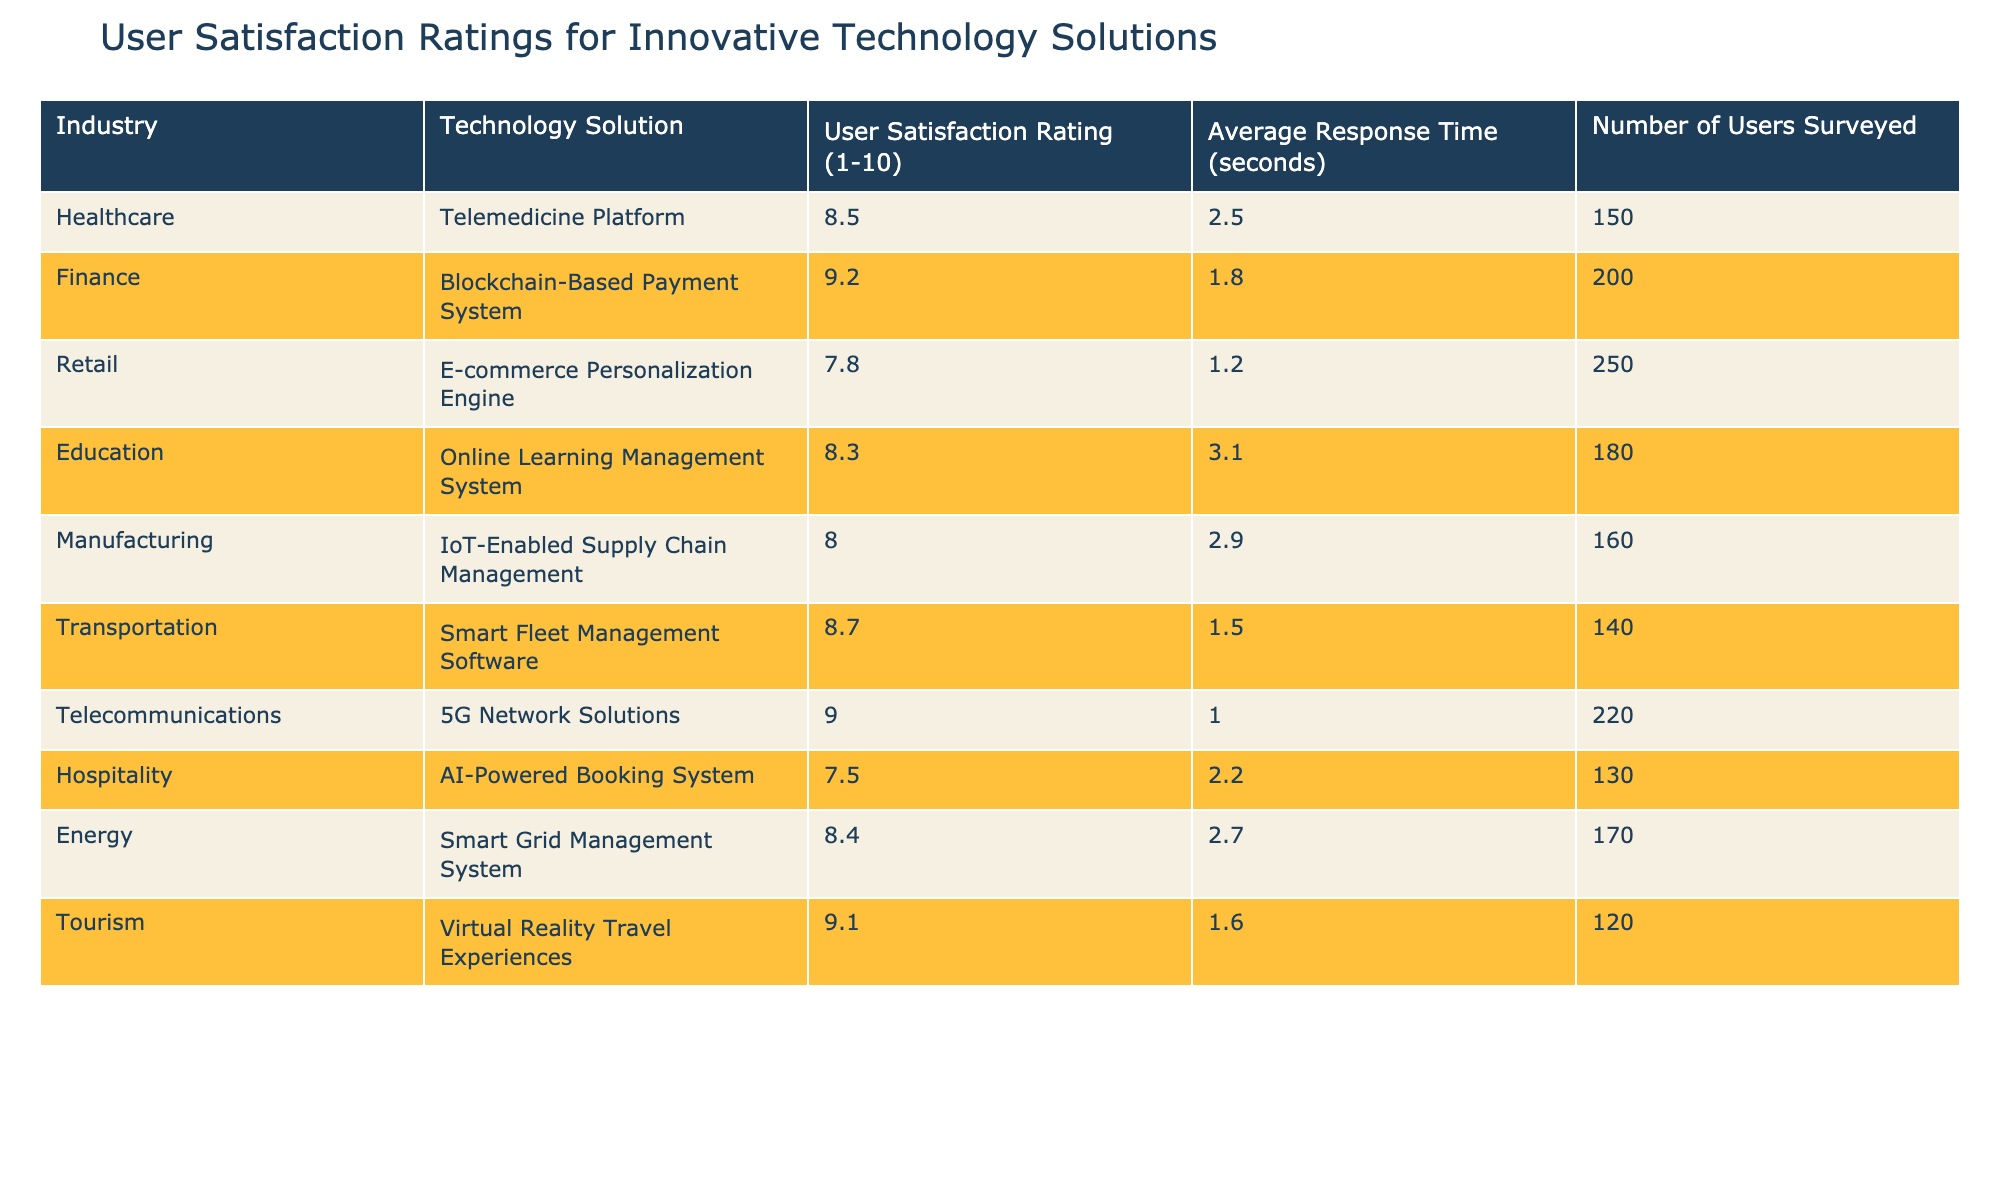What is the highest user satisfaction rating among the technology solutions? The table shows user satisfaction ratings for various technology solutions. Upon reviewing the ratings, the highest rating listed is 9.2 for the Blockchain-Based Payment System in the Finance industry.
Answer: 9.2 What is the average user satisfaction rating for the Healthcare and Education industries? The user satisfaction ratings for Healthcare and Education are 8.5 and 8.3, respectively. To calculate the average, add these two ratings (8.5 + 8.3 = 16.8) and divide by the number of industries, which is 2. Thus, the average is 16.8 / 2 = 8.4.
Answer: 8.4 Is the Average Response Time for the Tourism technology solution less than the average response time for the Energy technology solution? The Average Response Time for the Virtual Reality Travel Experiences in Tourism is 1.6 seconds, while for Smart Grid Management System in Energy, it is 2.7 seconds. Since 1.6 is less than 2.7, the statement is true.
Answer: Yes What is the user satisfaction rating difference between the Smart Fleet Management Software and AI-Powered Booking System? The user satisfaction ratings are 8.7 for Smart Fleet Management Software in Transportation and 7.5 for AI-Powered Booking System in Hospitality. To find the difference, subtract the lower rating from the higher rating: 8.7 - 7.5 = 1.2.
Answer: 1.2 How many users were surveyed for the E-commerce Personalization Engine, and is it more than the number of users surveyed for the Smart Fleet Management Software? The number of users surveyed for the E-commerce Personalization Engine in Retail is 250, while for Smart Fleet Management Software in Transportation, it is 140. Comparing these values, 250 is greater than 140.
Answer: Yes What is the average number of users surveyed across all technology solutions? To find the average number of users surveyed, we first sum the number of users from each solution: (150 + 200 + 250 + 180 + 160 + 140 + 220 + 130 + 170 + 120) = 1,870. Then, divide by the number of solutions, which is 10. The average is 1,870 / 10 = 187.
Answer: 187 Which industry has the lowest user satisfaction rating, and what is that rating? By reviewing the user satisfaction ratings in the table, the lowest rating is 7.5 for the AI-Powered Booking System in the Hospitality industry.
Answer: Hospitality, 7.5 Compare the Average Response Times for the Blockchain-Based Payment System and the IoT-Enabled Supply Chain Management. The Average Response Time for the Blockchain-Based Payment System in Finance is 1.8 seconds, and for the IoT-Enabled Supply Chain Management in Manufacturing, it is 2.9 seconds. Since 1.8 seconds is less than 2.9 seconds, it shows that the Blockchain solution has a shorter response time.
Answer: Blockchain is shorter 